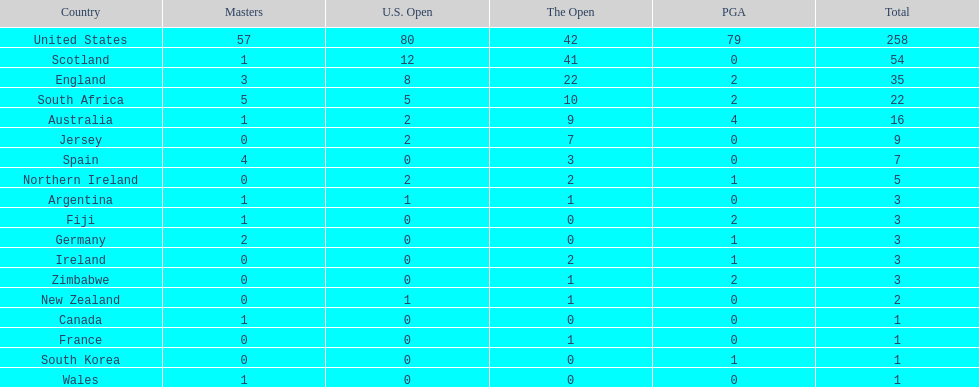How many u.s. open wins does fiji have? 0. 